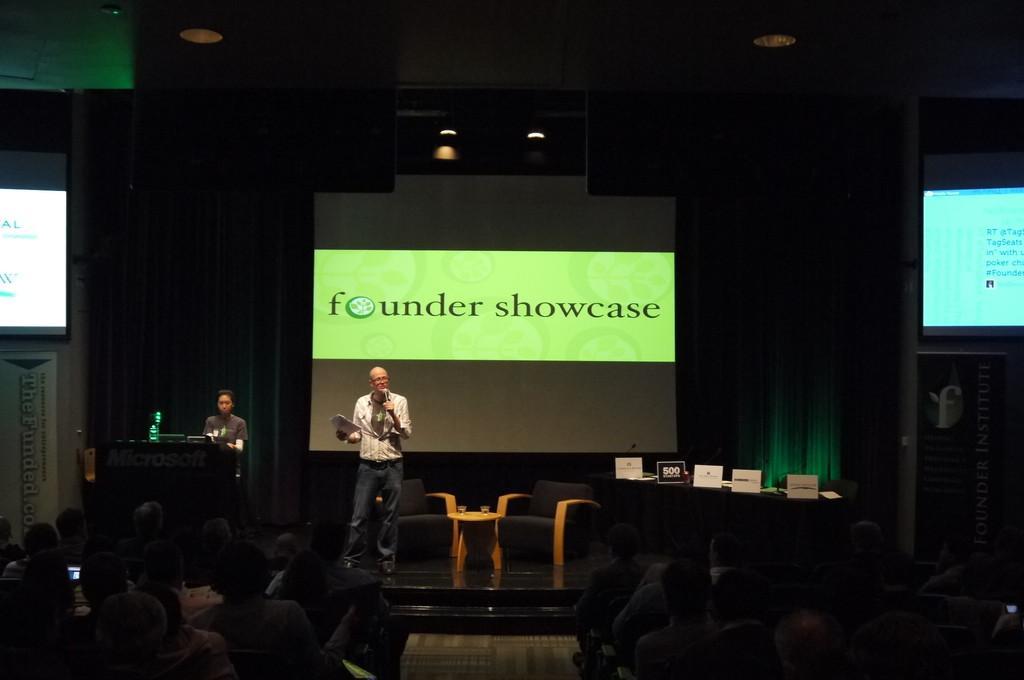How would you summarize this image in a sentence or two? In this image I see a man who is holding a mic and a papers in his hand. I can also see another person, 2 chairs and a table over here. In the background I see view people and a screen over here. 